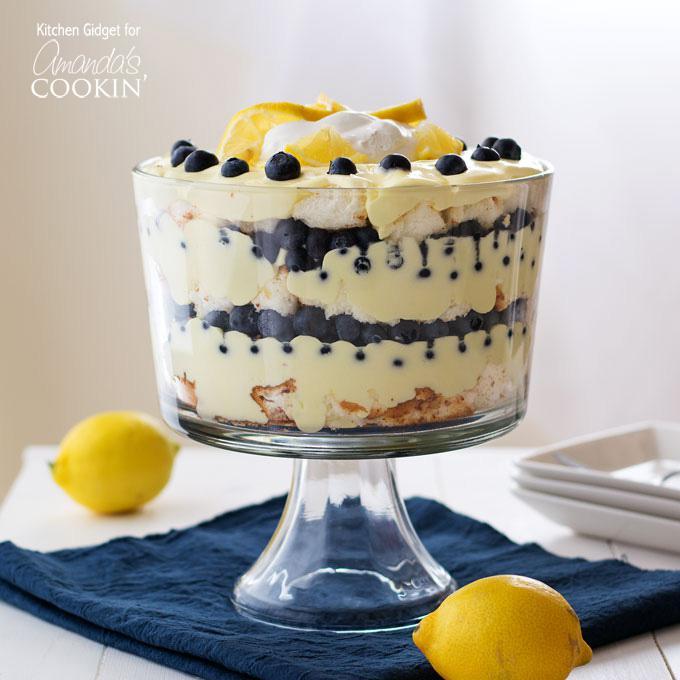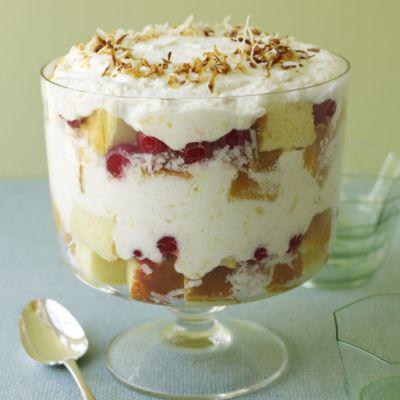The first image is the image on the left, the second image is the image on the right. For the images shown, is this caption "There are one or more spoons to the left of the truffle in one of the images." true? Answer yes or no. Yes. The first image is the image on the left, the second image is the image on the right. For the images shown, is this caption "One image in the pair contains a whole piece of fruit." true? Answer yes or no. Yes. 